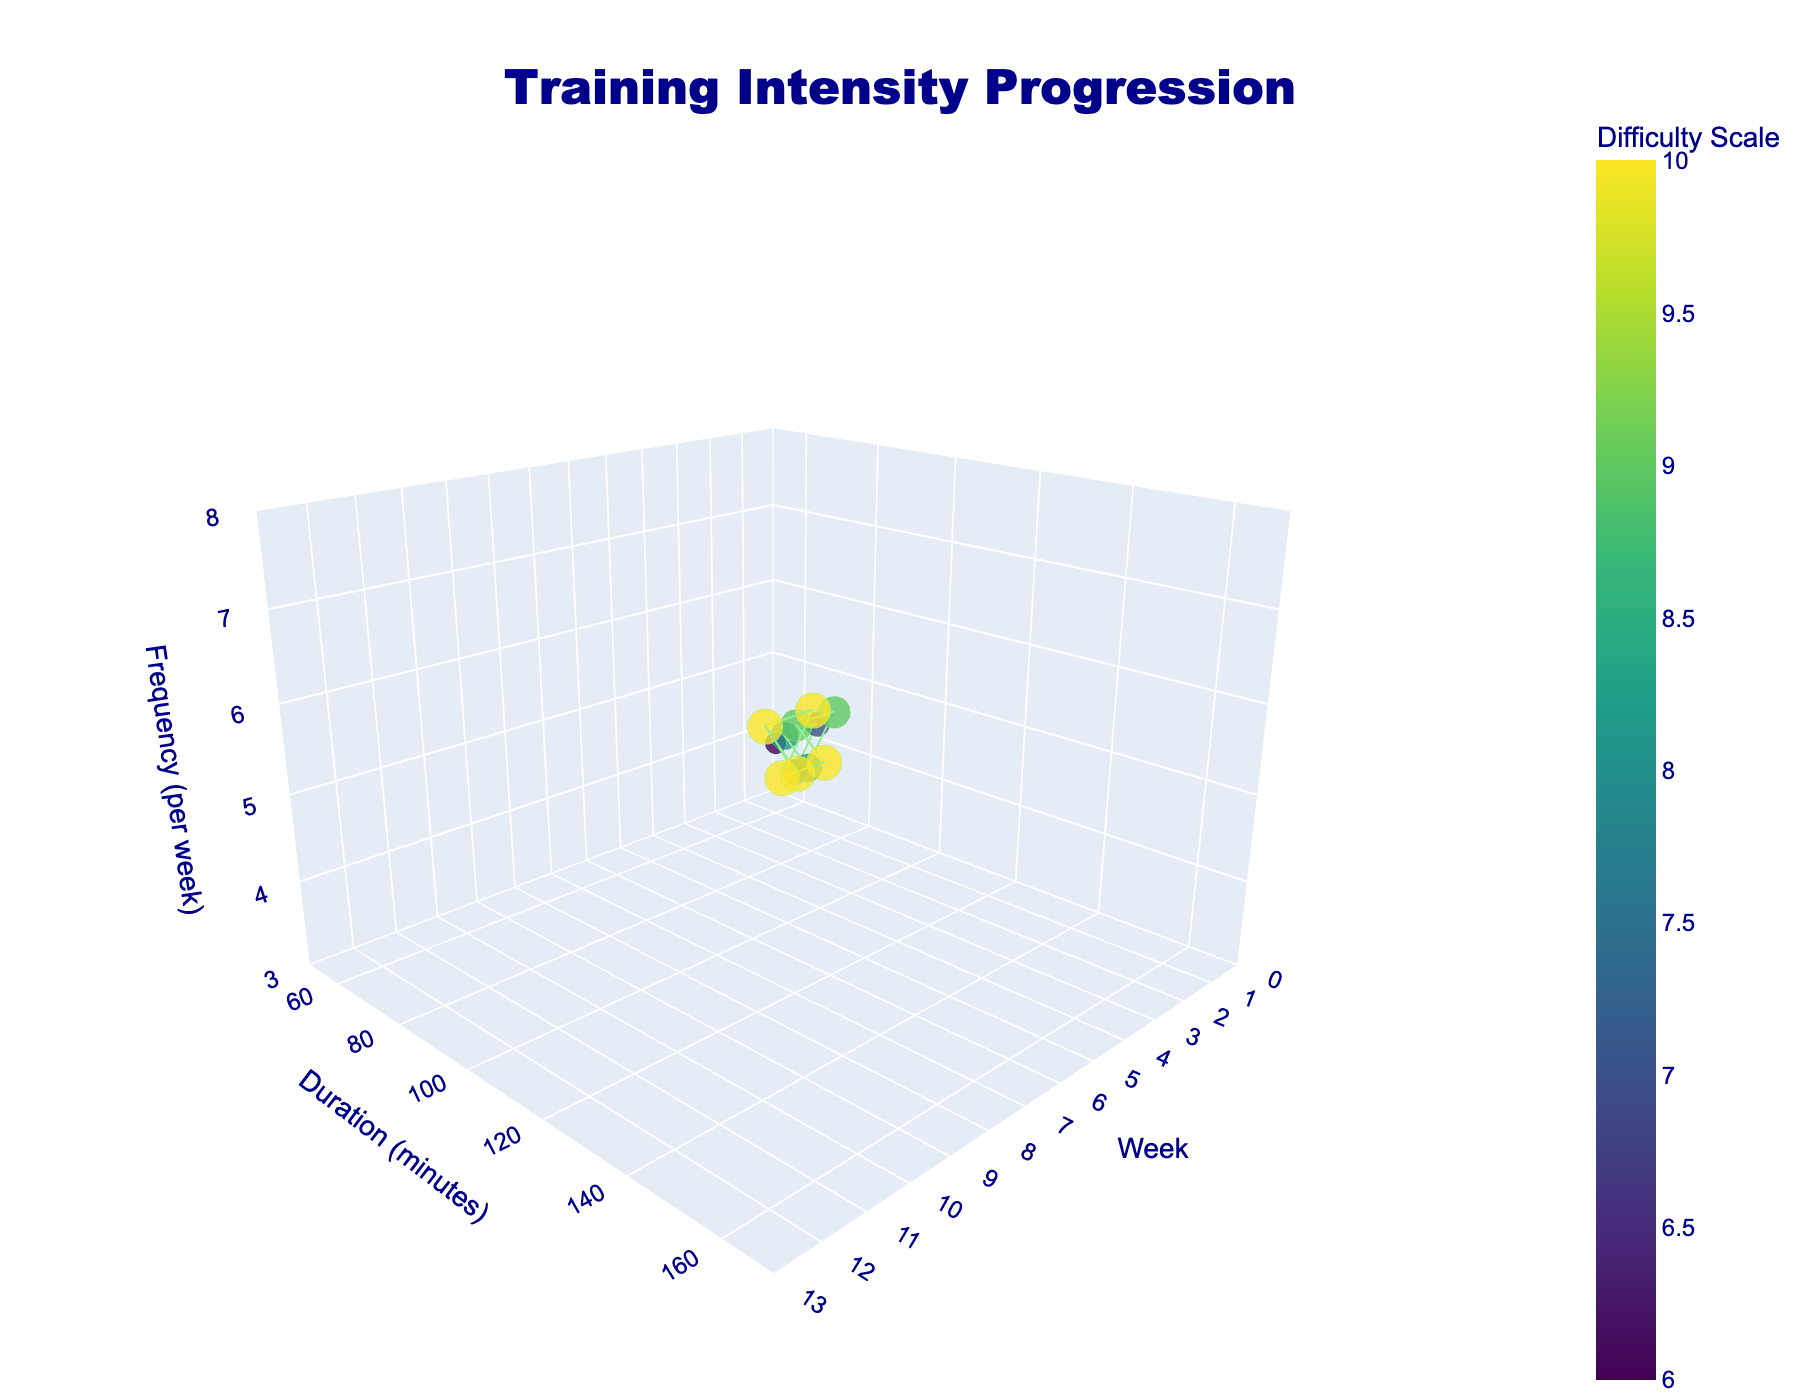What's the title of the figure? The title is specified at the top of the figure.
Answer: Training Intensity Progression Which week had the highest workout duration? By looking at the y-axis and the data points, identify the week with the highest y-value.
Answer: Week 12 What is the difficulty scale for Week 6? By hovering over the data point for Week 6, the difficulty scale is displayed in the hover template.
Answer: 9 What's the workout frequency in Week 10? The z-axis gives the frequency value, and hovering over Week 10 shows an exact number in the hover template.
Answer: 7 Between which two sequential weeks does the workout duration remain constant? By looking at the y-axis values, determine when there's no change in y-value between consecutive weeks.
Answer: Week 3 to Week 4 and Week 6 to Week 7 What's the duration increase between Week 1 and Week 2? Subtract the duration for Week 1 from the duration for Week 2 using the y-axis values. (75 - 60 = 15 minutes)
Answer: 15 minutes Which weeks have the same difficulty scale of 10? From the size and color of the markers, find the weeks with the difficulty scale value of 10.
Answer: Weeks 8, 9, 10, 11, 12 What is the average duration of workouts in the first 4 weeks? Add up the durations from Weeks 1-4 and divide by the number of weeks (60+75+90+90=315; 315/4=78.75).
Answer: 78.75 minutes Which week saw the biggest jump in workout duration compared to the previous week? Calculate the differences for each week and identify the largest one. (Week 11 to Week 12: 165-150=15 minutes)
Answer: Week 12 How does the workout frequency trend over the entire period? Check the z-axis values over time to observe the frequency trend.
Answer: Increasing trend 